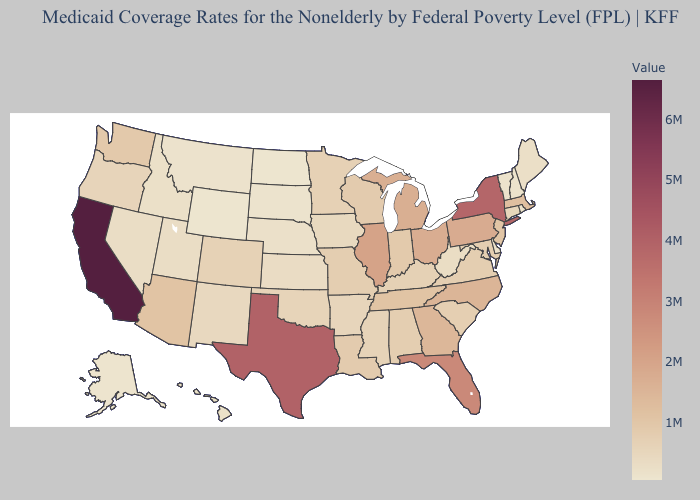Does Missouri have the highest value in the MidWest?
Answer briefly. No. Does California have the highest value in the USA?
Give a very brief answer. Yes. Among the states that border New York , which have the highest value?
Short answer required. Pennsylvania. Which states have the lowest value in the West?
Be succinct. Wyoming. Among the states that border Minnesota , does North Dakota have the lowest value?
Concise answer only. Yes. Which states have the lowest value in the MidWest?
Give a very brief answer. North Dakota. 